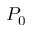<formula> <loc_0><loc_0><loc_500><loc_500>P _ { 0 }</formula> 